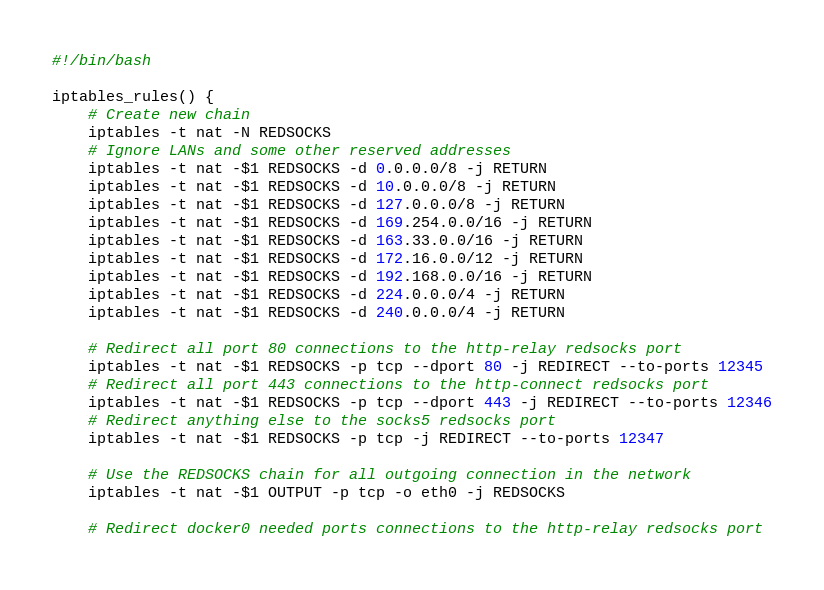<code> <loc_0><loc_0><loc_500><loc_500><_Bash_>#!/bin/bash

iptables_rules() {
    # Create new chain
    iptables -t nat -N REDSOCKS
    # Ignore LANs and some other reserved addresses
    iptables -t nat -$1 REDSOCKS -d 0.0.0.0/8 -j RETURN
    iptables -t nat -$1 REDSOCKS -d 10.0.0.0/8 -j RETURN
    iptables -t nat -$1 REDSOCKS -d 127.0.0.0/8 -j RETURN
    iptables -t nat -$1 REDSOCKS -d 169.254.0.0/16 -j RETURN
    iptables -t nat -$1 REDSOCKS -d 163.33.0.0/16 -j RETURN
    iptables -t nat -$1 REDSOCKS -d 172.16.0.0/12 -j RETURN
    iptables -t nat -$1 REDSOCKS -d 192.168.0.0/16 -j RETURN
    iptables -t nat -$1 REDSOCKS -d 224.0.0.0/4 -j RETURN
    iptables -t nat -$1 REDSOCKS -d 240.0.0.0/4 -j RETURN

    # Redirect all port 80 connections to the http-relay redsocks port
    iptables -t nat -$1 REDSOCKS -p tcp --dport 80 -j REDIRECT --to-ports 12345
    # Redirect all port 443 connections to the http-connect redsocks port
    iptables -t nat -$1 REDSOCKS -p tcp --dport 443 -j REDIRECT --to-ports 12346
    # Redirect anything else to the socks5 redsocks port
    iptables -t nat -$1 REDSOCKS -p tcp -j REDIRECT --to-ports 12347

    # Use the REDSOCKS chain for all outgoing connection in the network
    iptables -t nat -$1 OUTPUT -p tcp -o eth0 -j REDSOCKS

    # Redirect docker0 needed ports connections to the http-relay redsocks port</code> 